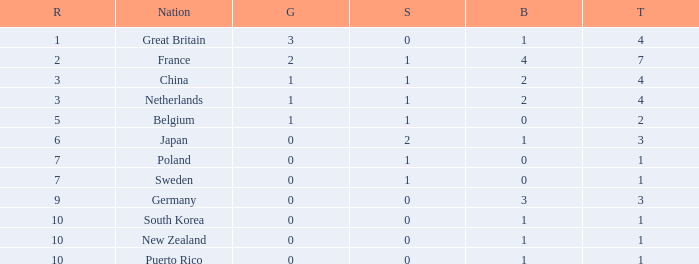What is the smallest number of gold where the total is less than 3 and the silver count is 2? None. 